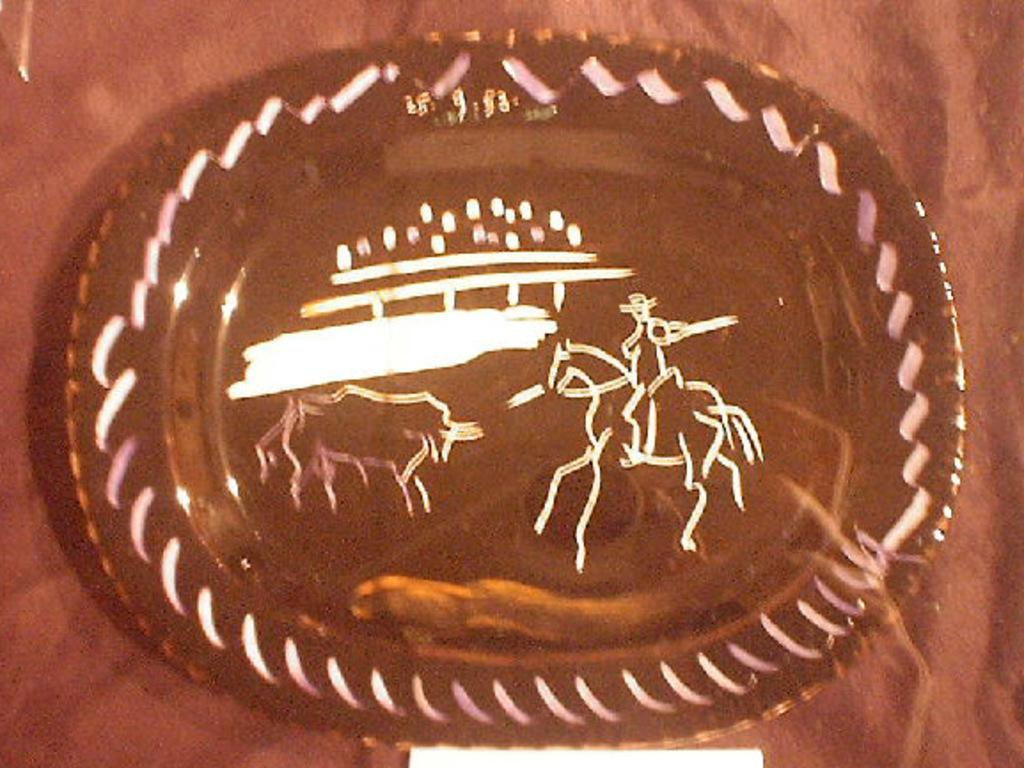What is located in the center of the image? There is a plate in the center of the image. On what surface is the plate placed? The plate is placed on a table. What type of throat-soothing remedy is visible on the plate in the image? There is no throat-soothing remedy present on the plate in the image. Is there an island visible in the image? There is no island present in the image. What type of flag is being waved in the image? There is no flag present in the image. 